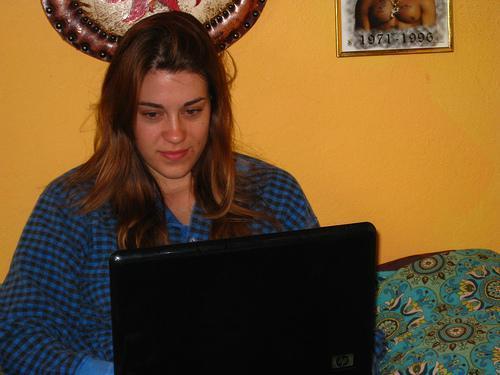How many computers are there?
Give a very brief answer. 1. 